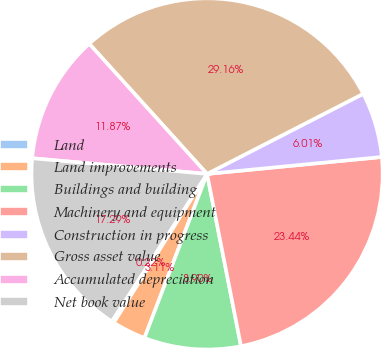Convert chart to OTSL. <chart><loc_0><loc_0><loc_500><loc_500><pie_chart><fcel>Land<fcel>Land improvements<fcel>Buildings and building<fcel>Machinery and equipment<fcel>Construction in progress<fcel>Gross asset value<fcel>Accumulated depreciation<fcel>Net book value<nl><fcel>0.22%<fcel>3.11%<fcel>8.9%<fcel>23.44%<fcel>6.01%<fcel>29.16%<fcel>11.87%<fcel>17.29%<nl></chart> 